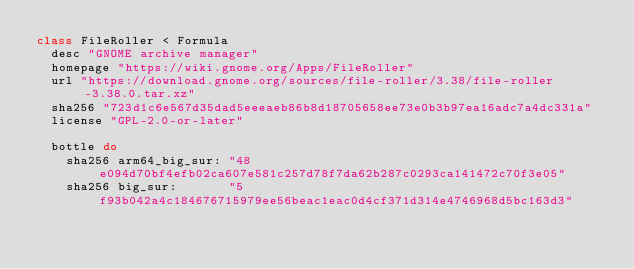Convert code to text. <code><loc_0><loc_0><loc_500><loc_500><_Ruby_>class FileRoller < Formula
  desc "GNOME archive manager"
  homepage "https://wiki.gnome.org/Apps/FileRoller"
  url "https://download.gnome.org/sources/file-roller/3.38/file-roller-3.38.0.tar.xz"
  sha256 "723d1c6e567d35dad5eeeaeb86b8d18705658ee73e0b3b97ea16adc7a4dc331a"
  license "GPL-2.0-or-later"

  bottle do
    sha256 arm64_big_sur: "48e094d70bf4efb02ca607e581c257d78f7da62b287c0293ca141472c70f3e05"
    sha256 big_sur:       "5f93b042a4c184676715979ee56beac1eac0d4cf371d314e4746968d5bc163d3"</code> 